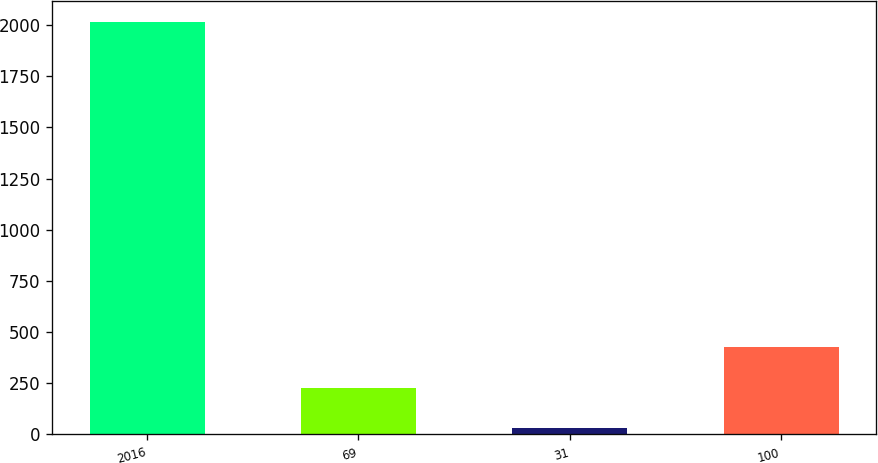Convert chart to OTSL. <chart><loc_0><loc_0><loc_500><loc_500><bar_chart><fcel>2016<fcel>69<fcel>31<fcel>100<nl><fcel>2015<fcel>229.4<fcel>31<fcel>427.8<nl></chart> 